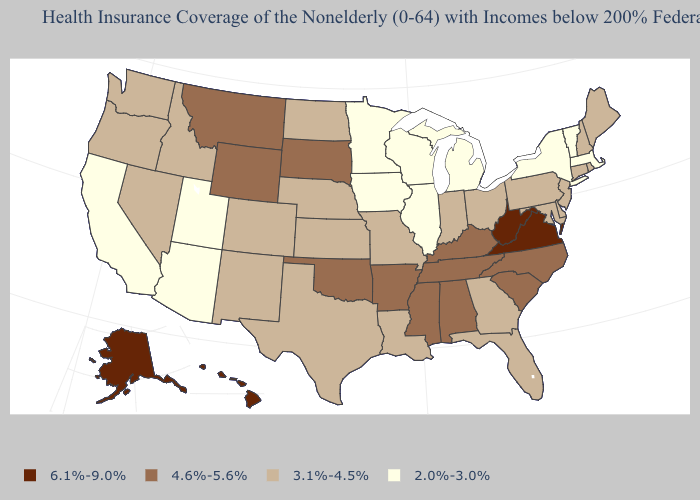Does West Virginia have the highest value in the USA?
Keep it brief. Yes. Name the states that have a value in the range 6.1%-9.0%?
Quick response, please. Alaska, Hawaii, Virginia, West Virginia. Among the states that border Massachusetts , does Connecticut have the highest value?
Concise answer only. Yes. Which states hav the highest value in the Northeast?
Write a very short answer. Connecticut, Maine, New Hampshire, New Jersey, Pennsylvania, Rhode Island. Name the states that have a value in the range 4.6%-5.6%?
Short answer required. Alabama, Arkansas, Kentucky, Mississippi, Montana, North Carolina, Oklahoma, South Carolina, South Dakota, Tennessee, Wyoming. What is the highest value in the West ?
Concise answer only. 6.1%-9.0%. What is the highest value in states that border New Jersey?
Give a very brief answer. 3.1%-4.5%. What is the lowest value in states that border Missouri?
Give a very brief answer. 2.0%-3.0%. What is the lowest value in the MidWest?
Quick response, please. 2.0%-3.0%. Name the states that have a value in the range 6.1%-9.0%?
Write a very short answer. Alaska, Hawaii, Virginia, West Virginia. Does Alaska have the highest value in the USA?
Quick response, please. Yes. Name the states that have a value in the range 2.0%-3.0%?
Write a very short answer. Arizona, California, Illinois, Iowa, Massachusetts, Michigan, Minnesota, New York, Utah, Vermont, Wisconsin. What is the value of Nebraska?
Answer briefly. 3.1%-4.5%. Does Rhode Island have the lowest value in the Northeast?
Concise answer only. No. What is the highest value in states that border Arkansas?
Give a very brief answer. 4.6%-5.6%. 